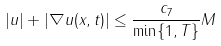Convert formula to latex. <formula><loc_0><loc_0><loc_500><loc_500>| u | + | \nabla u ( x , t ) | \leq \frac { c _ { 7 } } { \min \{ 1 , T \} } M</formula> 